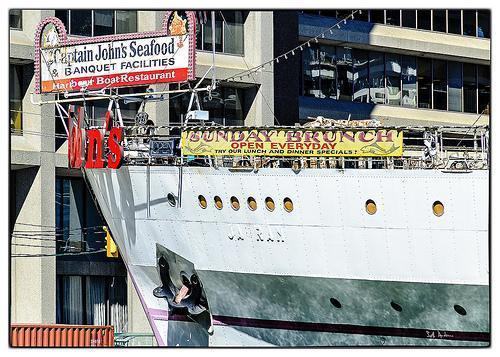How many yellow portholes are visible?
Give a very brief answer. 8. 